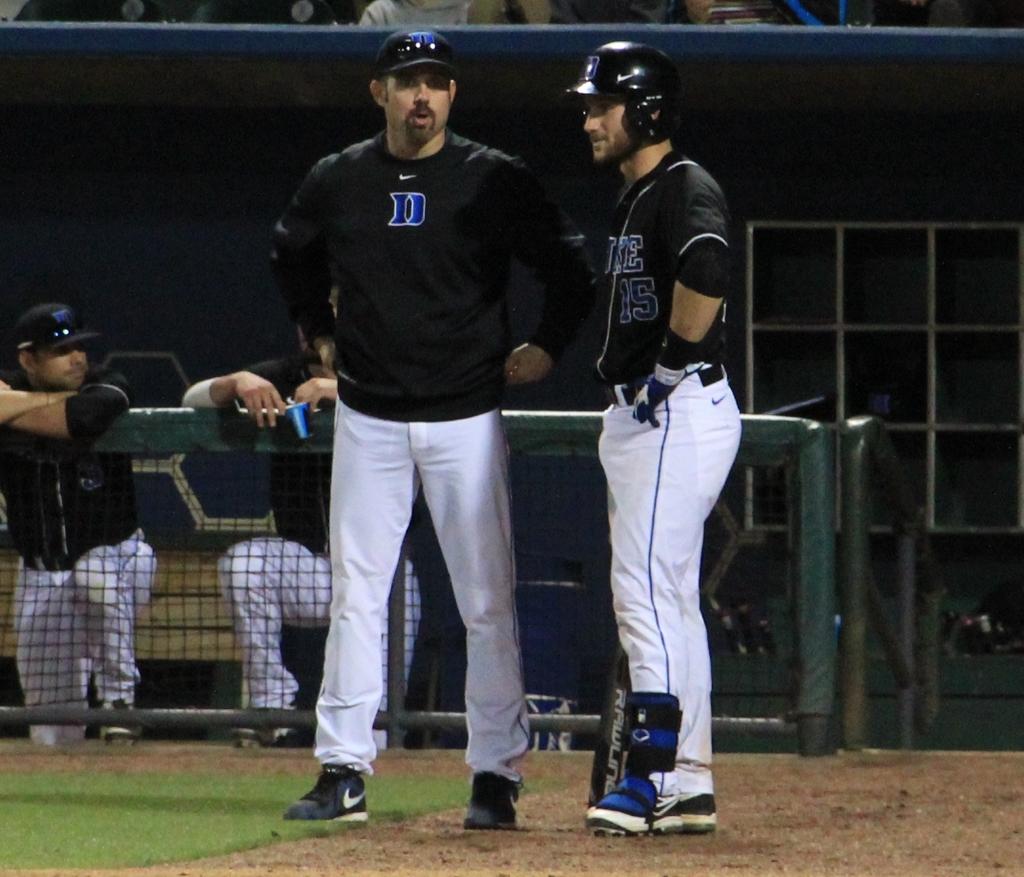What number is baseball player?
Keep it short and to the point. 15. 